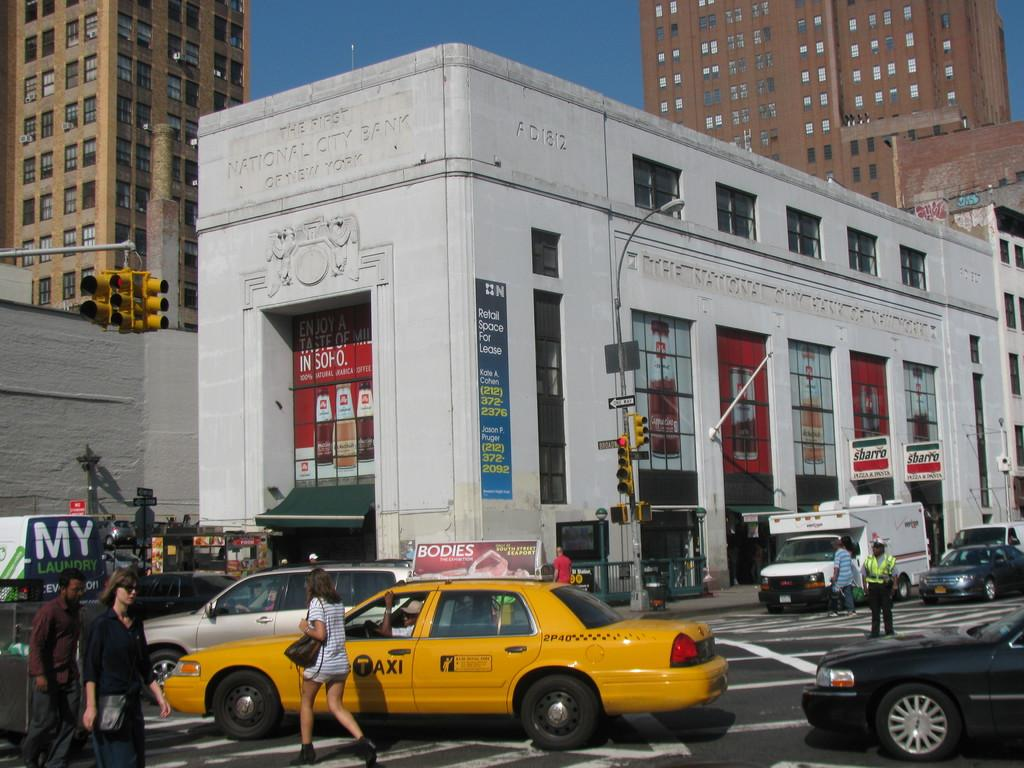<image>
Offer a succinct explanation of the picture presented. A taxi and other vehicles pass by a building with the sign the national city bank of new york 